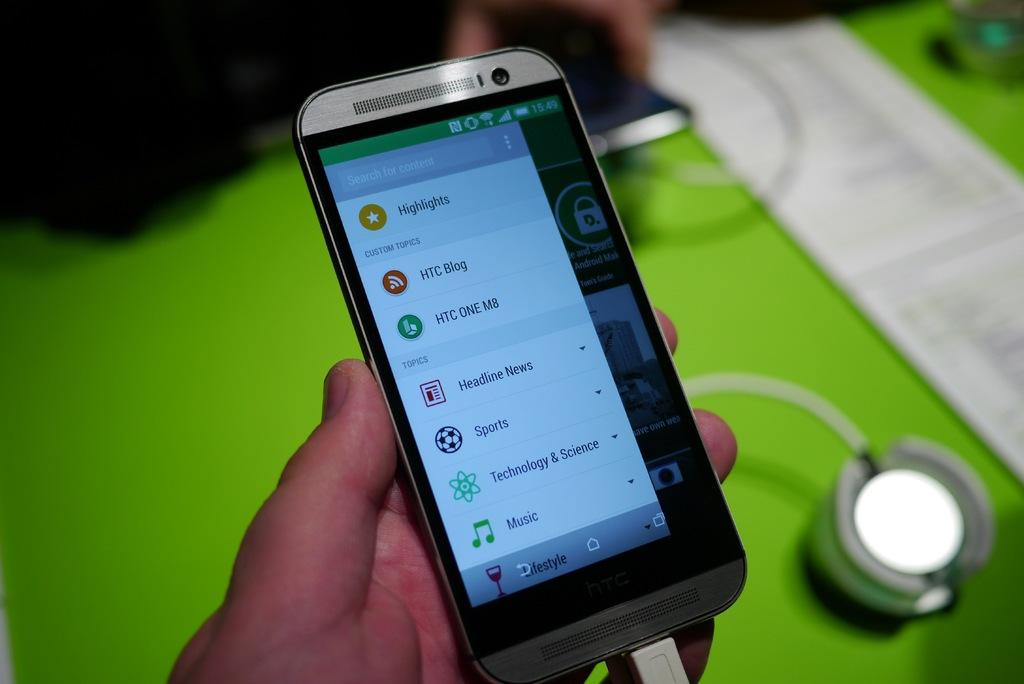<image>
Summarize the visual content of the image. A picture of a phone with the word Highlights visible at the top. 